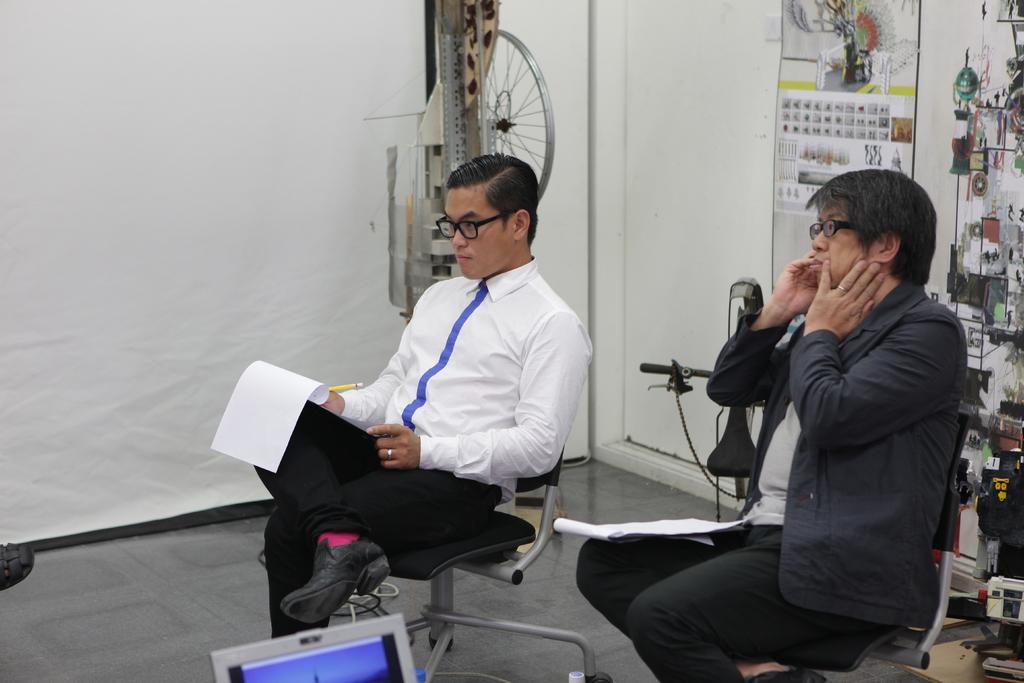How would you summarize this image in a sentence or two? In this image person wearing a white shirt is sitting on a chair. He is holding a paper and a pen in his hand. Beside him there is a person wearing a black jacket is sitting on the chair. He is having a paper on his lap. He is wearing spectacles. Right side there are few objects. A poster is attached to the wall which is having a door to it. Behind the persons there are few objects on the floor. Bottom of the image there is a laptop. 